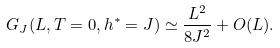<formula> <loc_0><loc_0><loc_500><loc_500>G _ { J } ( L , T = 0 , h ^ { \ast } = J ) \simeq \frac { L ^ { 2 } } { 8 J ^ { 2 } } + O ( L ) .</formula> 